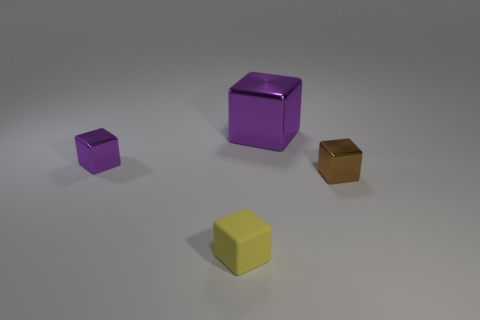Subtract all small brown metallic cubes. How many cubes are left? 3 Add 3 tiny gray matte objects. How many objects exist? 7 Subtract all purple blocks. How many blocks are left? 2 Subtract 3 blocks. How many blocks are left? 1 Subtract all green blocks. Subtract all blue spheres. How many blocks are left? 4 Add 4 small cubes. How many small cubes are left? 7 Add 4 big gray blocks. How many big gray blocks exist? 4 Subtract 0 cyan cylinders. How many objects are left? 4 Subtract all red balls. How many brown cubes are left? 1 Subtract all small blocks. Subtract all big red shiny cylinders. How many objects are left? 1 